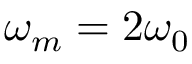<formula> <loc_0><loc_0><loc_500><loc_500>\omega _ { m } = 2 \omega _ { 0 }</formula> 